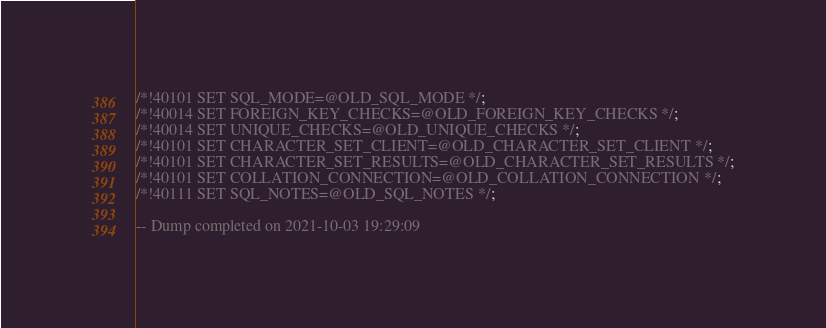Convert code to text. <code><loc_0><loc_0><loc_500><loc_500><_SQL_>/*!40101 SET SQL_MODE=@OLD_SQL_MODE */;
/*!40014 SET FOREIGN_KEY_CHECKS=@OLD_FOREIGN_KEY_CHECKS */;
/*!40014 SET UNIQUE_CHECKS=@OLD_UNIQUE_CHECKS */;
/*!40101 SET CHARACTER_SET_CLIENT=@OLD_CHARACTER_SET_CLIENT */;
/*!40101 SET CHARACTER_SET_RESULTS=@OLD_CHARACTER_SET_RESULTS */;
/*!40101 SET COLLATION_CONNECTION=@OLD_COLLATION_CONNECTION */;
/*!40111 SET SQL_NOTES=@OLD_SQL_NOTES */;

-- Dump completed on 2021-10-03 19:29:09
</code> 